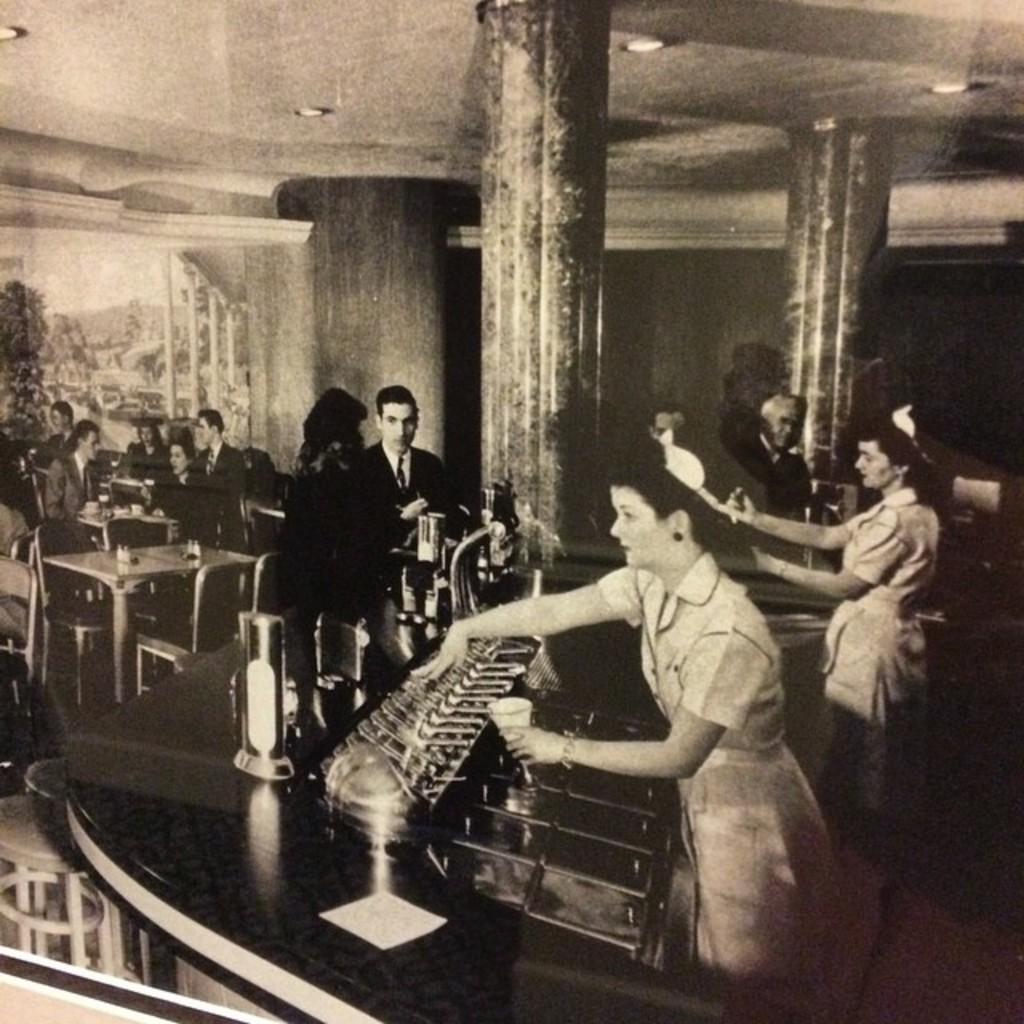Can you describe this image briefly? In this picture I can see there are a group of people standing here and they have a wine glasses and there are some other people sitting here and there are some other people here and in the backdrop there is a wall. 